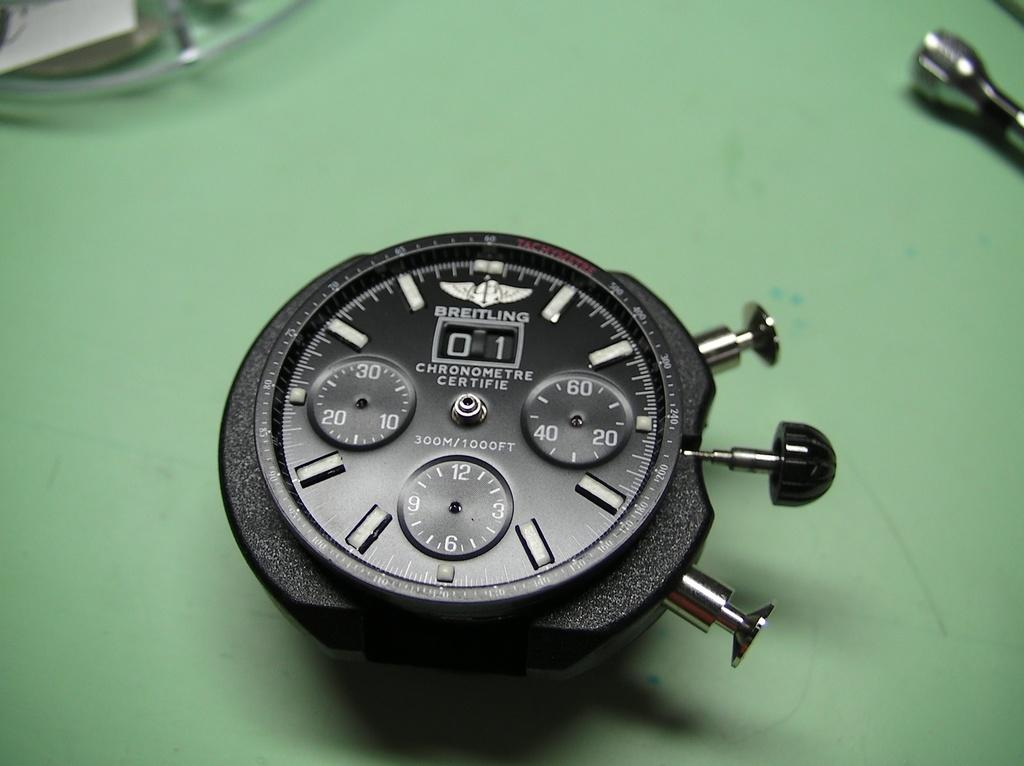<image>
Provide a brief description of the given image. A Breitling stopwatch is missing its hands and is lying on a green table. 